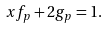<formula> <loc_0><loc_0><loc_500><loc_500>x f _ { p } + 2 g _ { p } = 1 .</formula> 